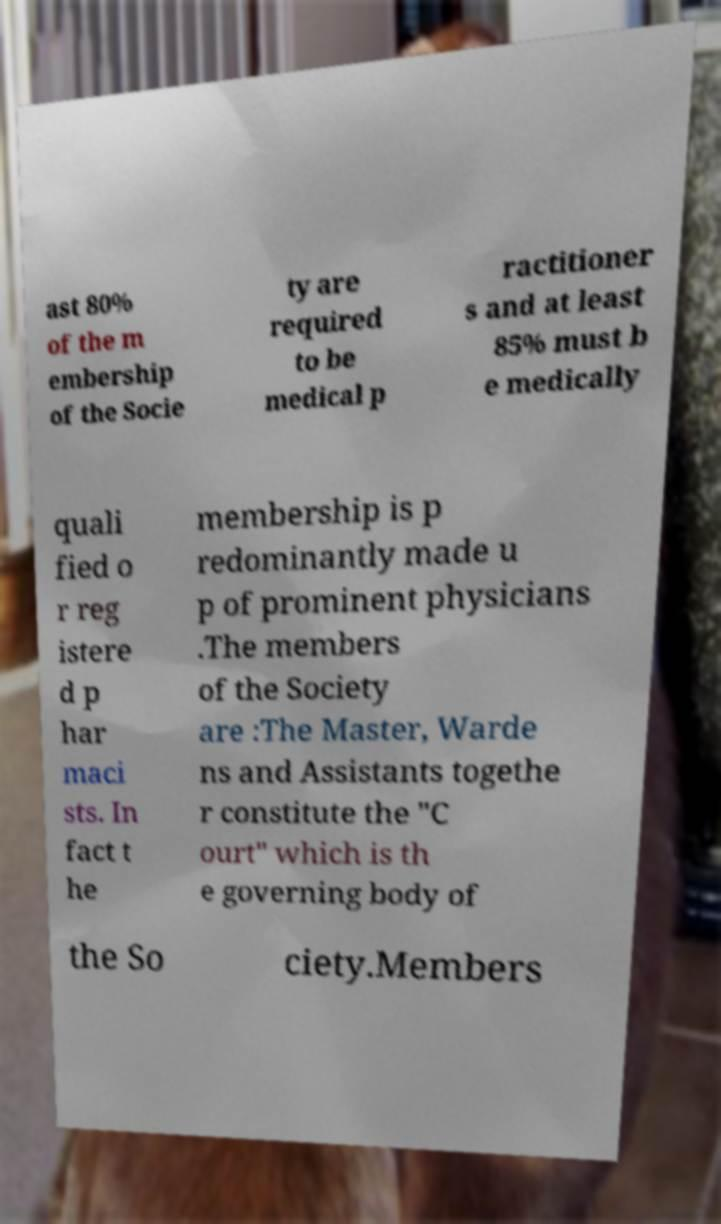There's text embedded in this image that I need extracted. Can you transcribe it verbatim? ast 80% of the m embership of the Socie ty are required to be medical p ractitioner s and at least 85% must b e medically quali fied o r reg istere d p har maci sts. In fact t he membership is p redominantly made u p of prominent physicians .The members of the Society are :The Master, Warde ns and Assistants togethe r constitute the "C ourt" which is th e governing body of the So ciety.Members 